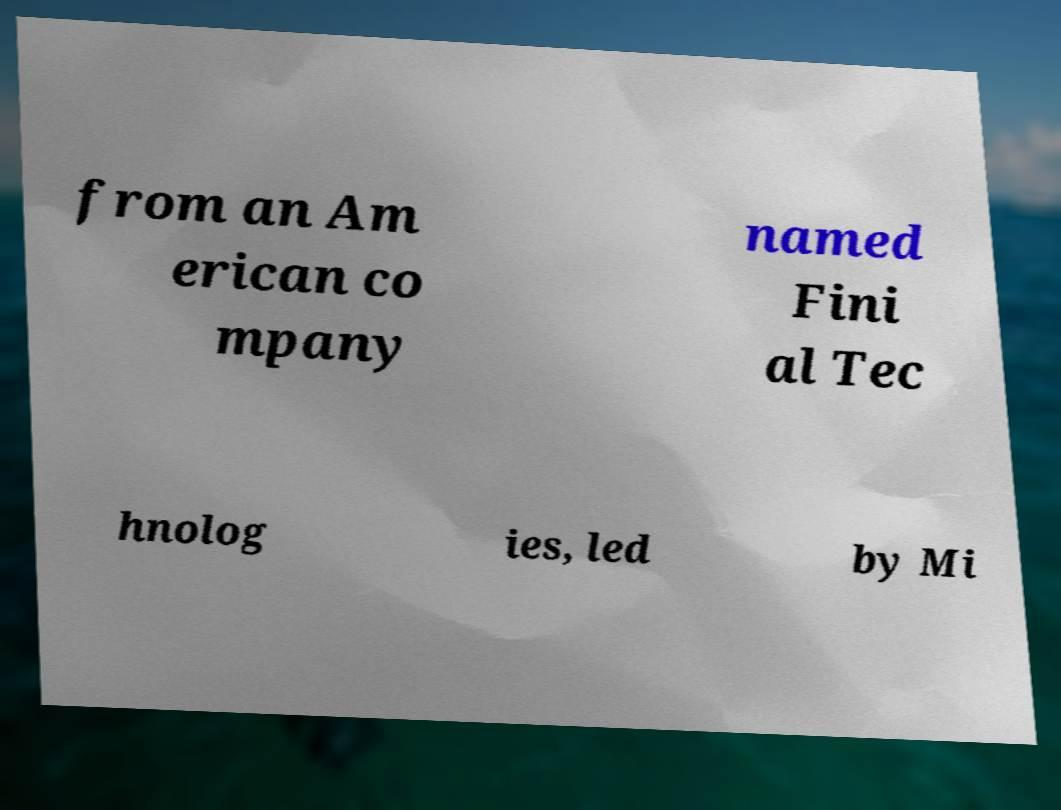Could you assist in decoding the text presented in this image and type it out clearly? from an Am erican co mpany named Fini al Tec hnolog ies, led by Mi 